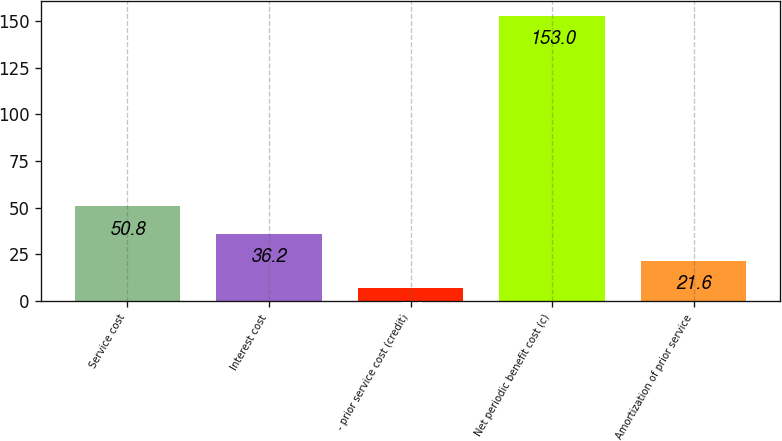Convert chart to OTSL. <chart><loc_0><loc_0><loc_500><loc_500><bar_chart><fcel>Service cost<fcel>Interest cost<fcel>- prior service cost (credit)<fcel>Net periodic benefit cost (c)<fcel>Amortization of prior service<nl><fcel>50.8<fcel>36.2<fcel>7<fcel>153<fcel>21.6<nl></chart> 